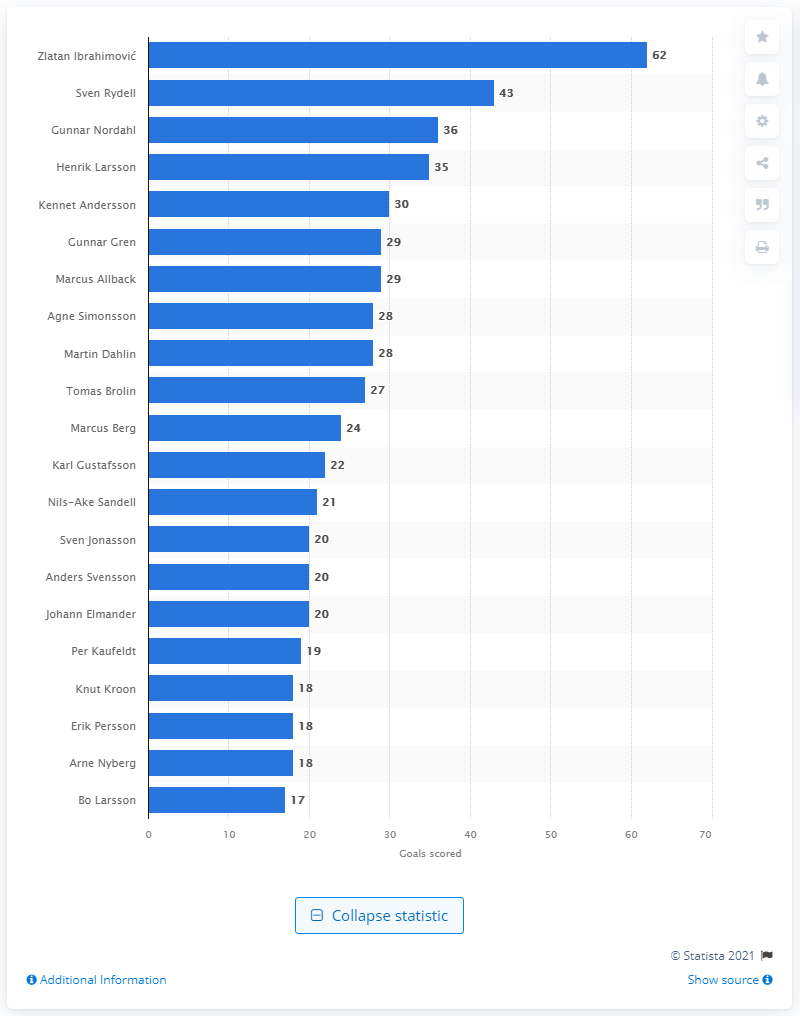Point out several critical features in this image. Zlatan Ibrahimovi has scored a grand total of 62 goals! Sven Rydell is the leading goal scorer for Sweden's national football team. 